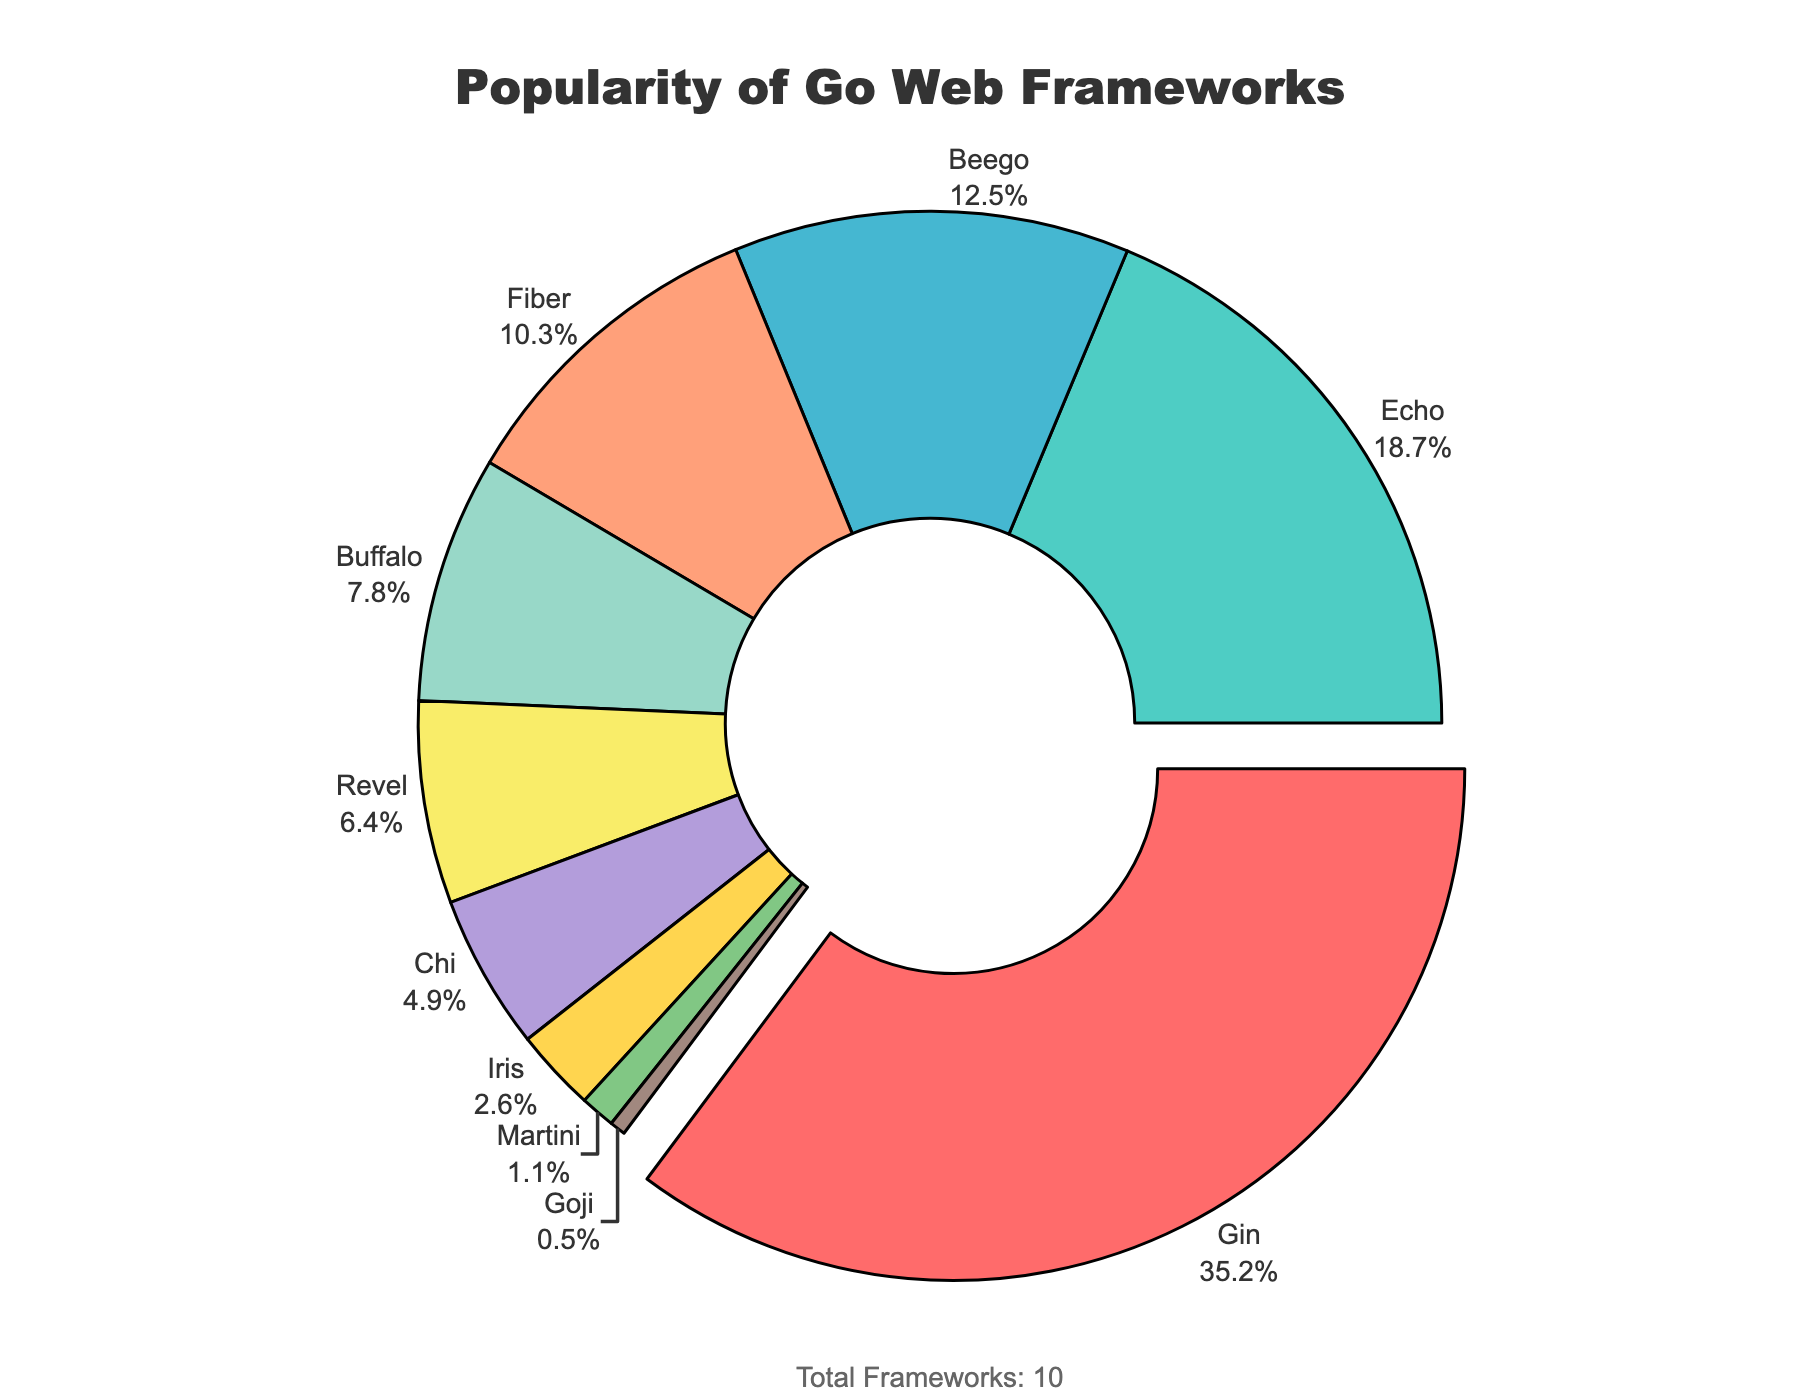How many frameworks have a popularity higher than 10%? We need to identify the frameworks with a percentage greater than 10%. Gin (35.2%), Echo (18.7%), Beego (12.5%), and Fiber (10.3%) meet this criterion. Therefore, there are 4 frameworks.
Answer: 4 Which framework is the least popular and what is its percentage? Looking at the percentages in descending order, Goji has the smallest value with 0.5%. Therefore, Goji is the least popular framework.
Answer: Goji, 0.5% What is the combined percentage of Beego and Buffalo? Beego has 12.5% and Buffalo has 7.8%. Adding these two percentages: 12.5% + 7.8% = 20.3%.
Answer: 20.3% Is the popularity of Revel closer to Fiber or Chi? Revel has 6.4%, Fiber has 10.3%, and Chi has 4.9%. The difference between Revel and Fiber is 10.3% - 6.4% = 3.9%. The difference between Revel and Chi is 6.4% - 4.9% = 1.5%. Therefore, Revel is closer in popularity to Chi.
Answer: Chi What color represents the Echo framework? Echo is represented as the second framework in both the data and the pie chart. The second color is green. Therefore, Echo is green.
Answer: Green What percentage of the frameworks combine to make up more than 70% of the total popularity? Adding the percentages from highest until we exceed 70%: Gin (35.2%) + Echo (18.7%) + Beego (12.5%) = 66.4%. Adding Fiber next: 66.4% + 10.3% = 76.7%. Thus, Gin, Echo, Beego, and Fiber combined make up more than 70%.
Answer: Four frameworks By what percentage is Gin more popular than Fiber? Gin has a popularity of 35.2%, while Fiber has 10.3%. The difference is 35.2% - 10.3% = 24.9%. Hence, Gin is 24.9% more popular than Fiber.
Answer: 24.9% What is the average percentage of the top three most popular frameworks? Gin (35.2%), Echo (18.7%), and Beego (12.5%) are the top three. Adding them up: 35.2% + 18.7% + 12.5% = 66.4%. The average is 66.4% / 3 = 22.13%.
Answer: 22.13% Which framework has an orange color in the pie chart? The fourth color in the color sequence is orange. Therefore, the fourth framework, Fiber, is represented with an orange color.
Answer: Fiber 